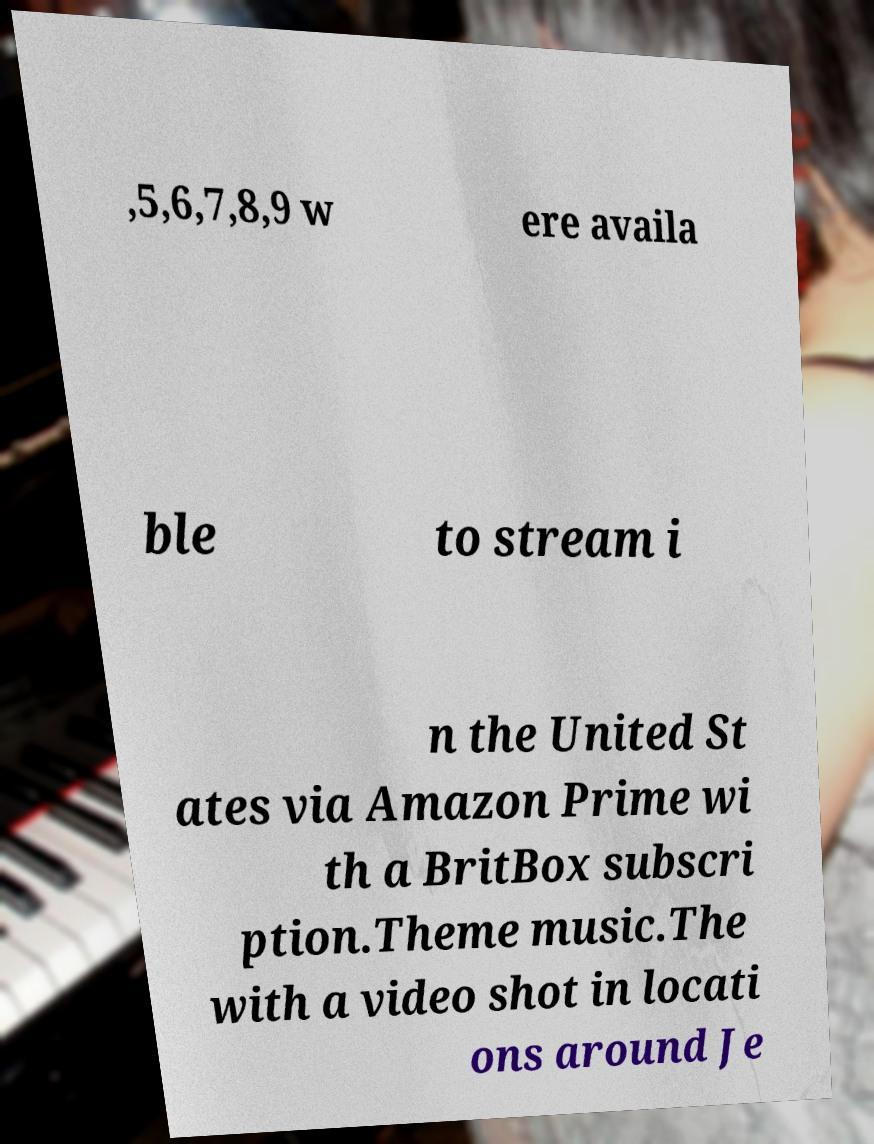For documentation purposes, I need the text within this image transcribed. Could you provide that? ,5,6,7,8,9 w ere availa ble to stream i n the United St ates via Amazon Prime wi th a BritBox subscri ption.Theme music.The with a video shot in locati ons around Je 